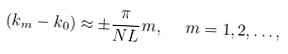Convert formula to latex. <formula><loc_0><loc_0><loc_500><loc_500>\left ( k _ { m } - k _ { 0 } \right ) \approx \pm \frac { \pi } { N L } m , \ \ m = 1 , 2 , \dots ,</formula> 